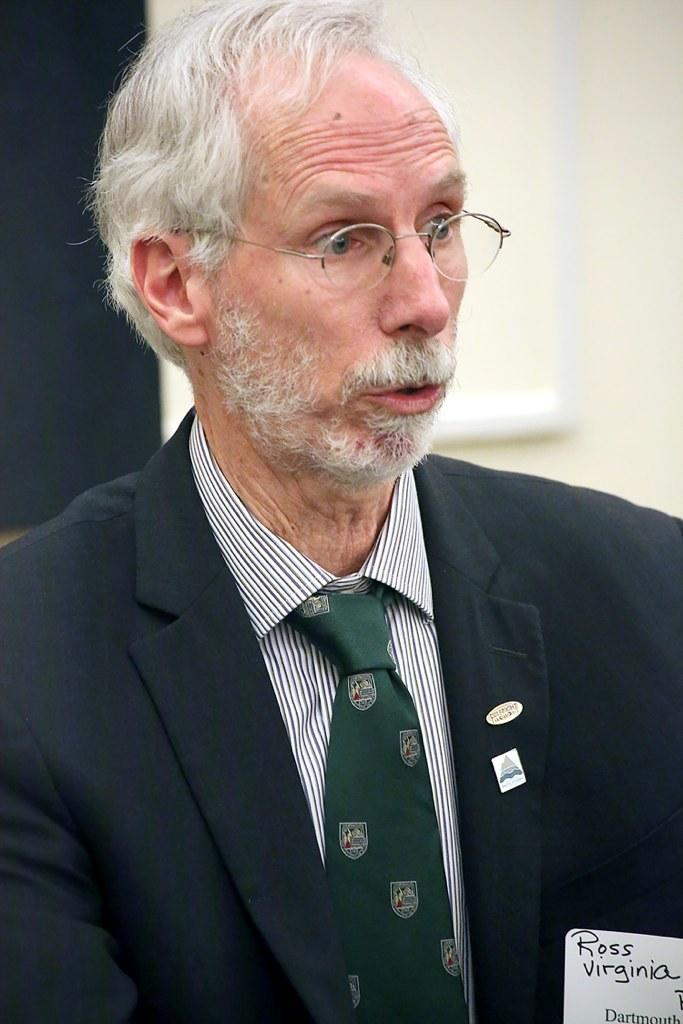What is present in the image? There is a man in the image. Can you describe the man's appearance? The man is wearing spectacles. What can be observed about the background of the image? The background of the image is blurred. What type of pie is the man holding in the image? There is no pie present in the image; the man is not holding any pie. What type of notebook is the man using to take notes in the image? There is no notebook present in the image, and the man is not taking notes. 